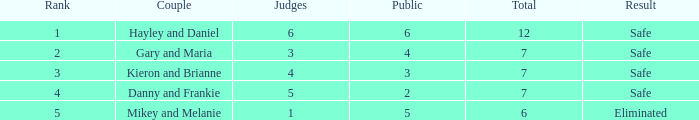What was the result for the total of 12? Safe. 